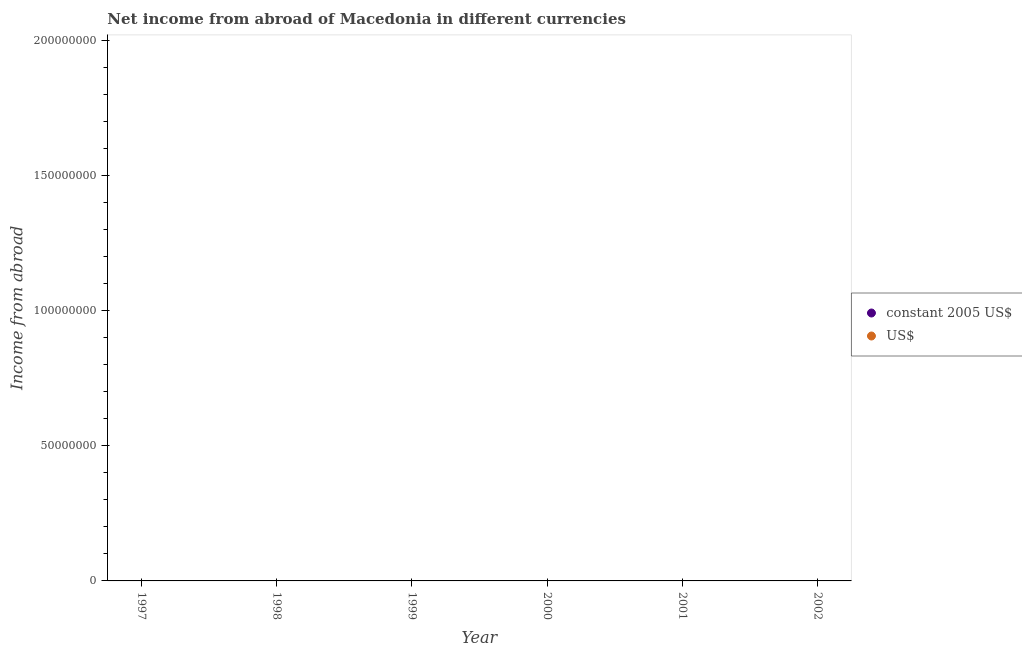What is the income from abroad in us$ in 2000?
Offer a very short reply. 0. Across all years, what is the minimum income from abroad in us$?
Ensure brevity in your answer.  0. In how many years, is the income from abroad in constant 2005 us$ greater than the average income from abroad in constant 2005 us$ taken over all years?
Give a very brief answer. 0. Does the income from abroad in us$ monotonically increase over the years?
Make the answer very short. No. Are the values on the major ticks of Y-axis written in scientific E-notation?
Keep it short and to the point. No. Does the graph contain grids?
Your answer should be compact. No. Where does the legend appear in the graph?
Provide a succinct answer. Center right. What is the title of the graph?
Your answer should be compact. Net income from abroad of Macedonia in different currencies. What is the label or title of the Y-axis?
Give a very brief answer. Income from abroad. What is the Income from abroad of constant 2005 US$ in 1997?
Your answer should be compact. 0. What is the Income from abroad of constant 2005 US$ in 1998?
Make the answer very short. 0. What is the Income from abroad in constant 2005 US$ in 2001?
Provide a succinct answer. 0. What is the Income from abroad of US$ in 2002?
Keep it short and to the point. 0. 